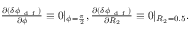<formula> <loc_0><loc_0><loc_500><loc_500>\begin{array} { r } { \frac { \partial ( \delta \phi _ { d f } ) } { \partial \phi } \equiv 0 | _ { \phi = \frac { \pi } { 2 } } , \frac { \partial ( \delta \phi _ { d f } ) } { \partial R _ { 2 } } \equiv 0 | _ { R _ { 2 } = 0 . 5 } . } \end{array}</formula> 